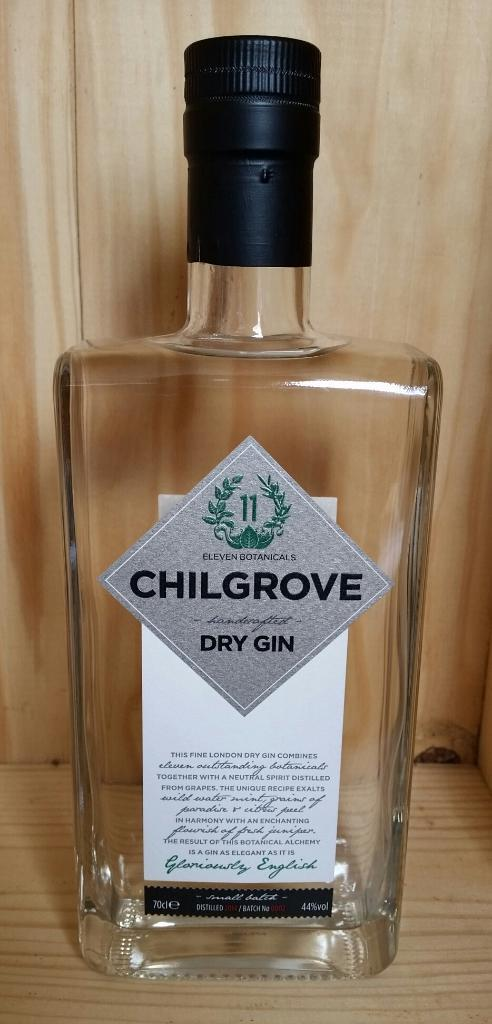What object is visible on the table in the image? There is a bottle in the image. Where is the bottle located in the image? The bottle is on a table. What type of belief does the bottle hold in the image? The bottle does not hold any beliefs; it is an inanimate object. Can you tell me how many family members are present in the image? There is no reference to any family members in the image; it only features a bottle on a table. 